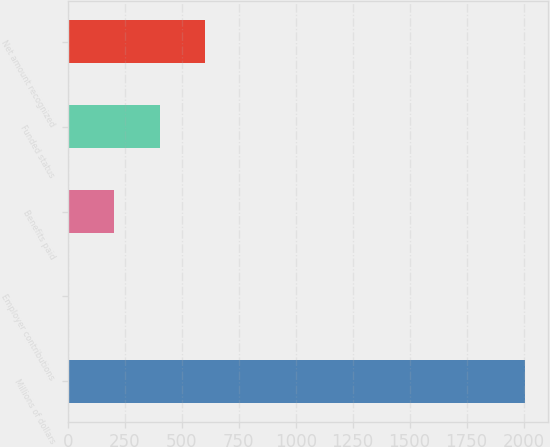<chart> <loc_0><loc_0><loc_500><loc_500><bar_chart><fcel>Millions of dollars<fcel>Employer contributions<fcel>Benefits paid<fcel>Funded status<fcel>Net amount recognized<nl><fcel>2008<fcel>1<fcel>201.7<fcel>402.4<fcel>603.1<nl></chart> 